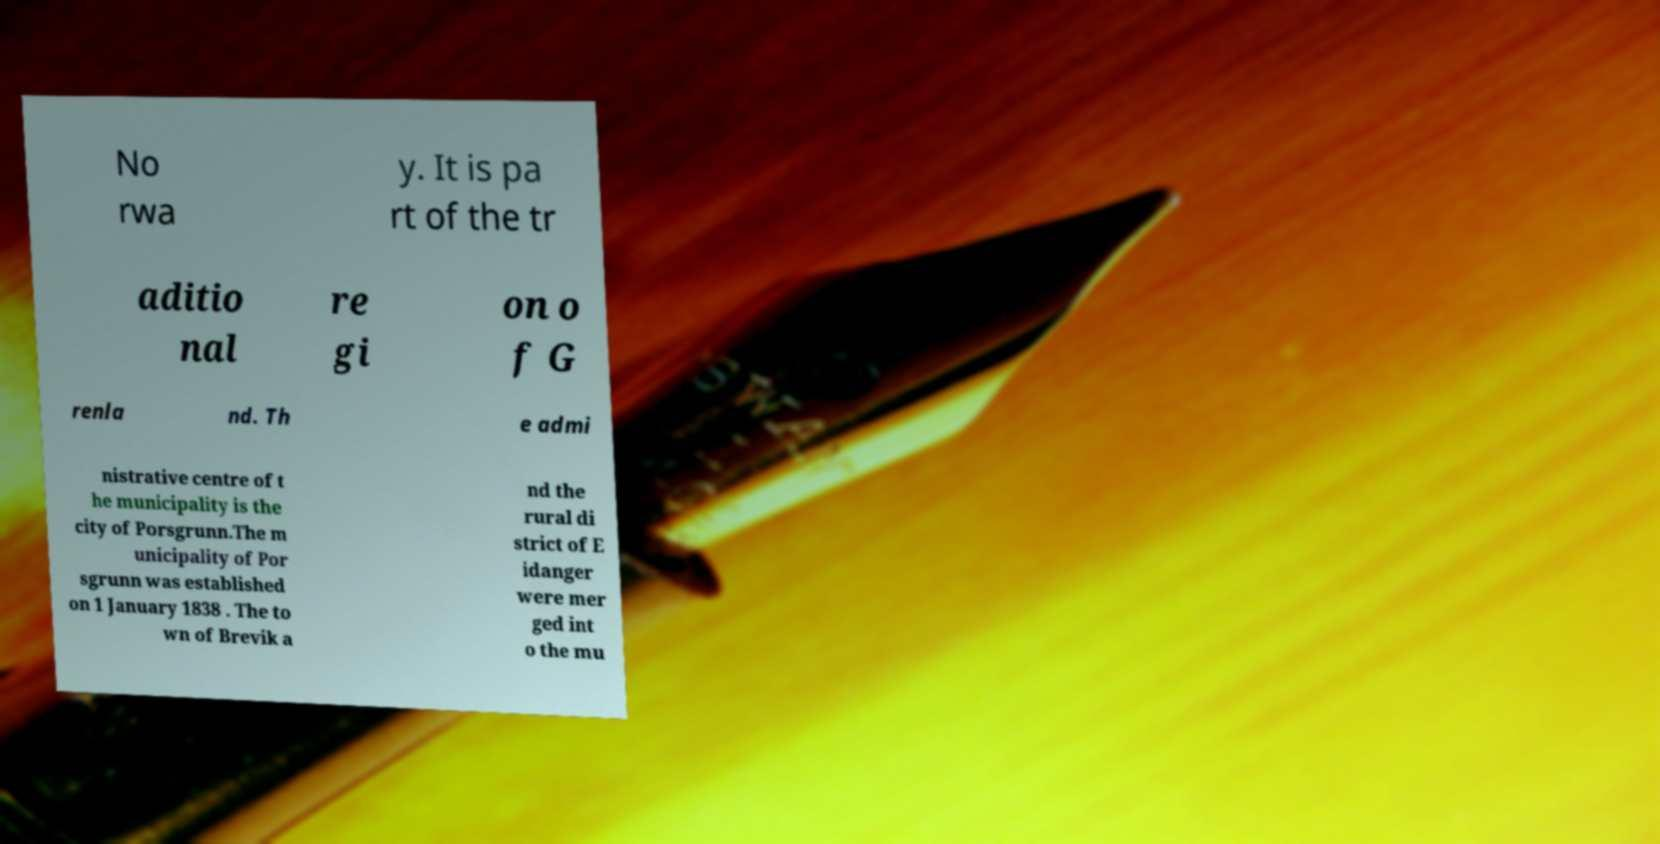What messages or text are displayed in this image? I need them in a readable, typed format. No rwa y. It is pa rt of the tr aditio nal re gi on o f G renla nd. Th e admi nistrative centre of t he municipality is the city of Porsgrunn.The m unicipality of Por sgrunn was established on 1 January 1838 . The to wn of Brevik a nd the rural di strict of E idanger were mer ged int o the mu 